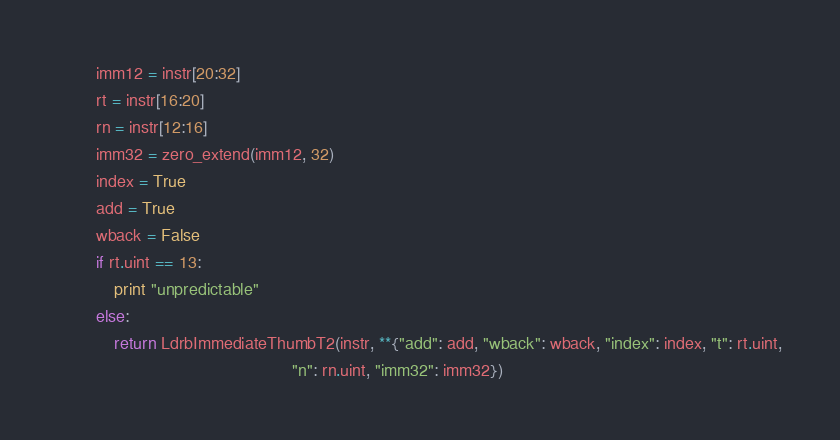<code> <loc_0><loc_0><loc_500><loc_500><_Python_>        imm12 = instr[20:32]
        rt = instr[16:20]
        rn = instr[12:16]
        imm32 = zero_extend(imm12, 32)
        index = True
        add = True
        wback = False
        if rt.uint == 13:
            print "unpredictable"
        else:
            return LdrbImmediateThumbT2(instr, **{"add": add, "wback": wback, "index": index, "t": rt.uint,
                                                  "n": rn.uint, "imm32": imm32})
</code> 